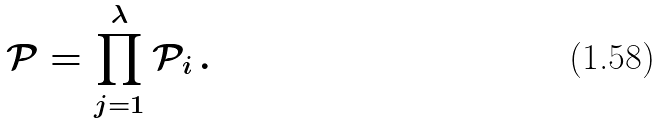Convert formula to latex. <formula><loc_0><loc_0><loc_500><loc_500>\mathcal { P } = \prod _ { j = 1 } ^ { \lambda } \mathcal { P } _ { i } \, .</formula> 